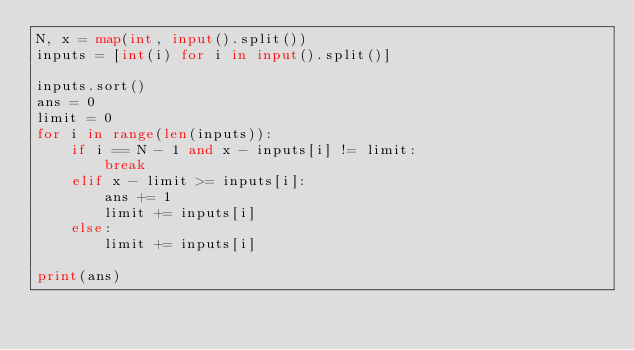<code> <loc_0><loc_0><loc_500><loc_500><_Python_>N, x = map(int, input().split())
inputs = [int(i) for i in input().split()]

inputs.sort()
ans = 0
limit = 0
for i in range(len(inputs)):
    if i == N - 1 and x - inputs[i] != limit:
        break
    elif x - limit >= inputs[i]:
        ans += 1
        limit += inputs[i]
    else:
        limit += inputs[i]

print(ans)
</code> 